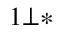Convert formula to latex. <formula><loc_0><loc_0><loc_500><loc_500>^ { 1 \bot \ast }</formula> 